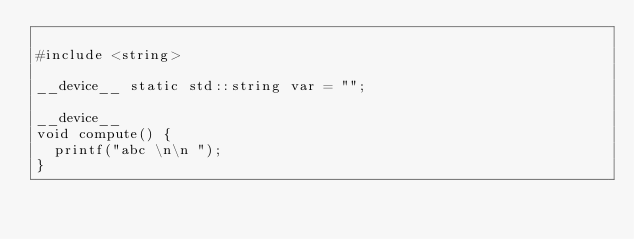Convert code to text. <code><loc_0><loc_0><loc_500><loc_500><_Cuda_>
#include <string>

__device__ static std::string var = "";

__device__
void compute() {
  printf("abc \n\n ");
}
</code> 